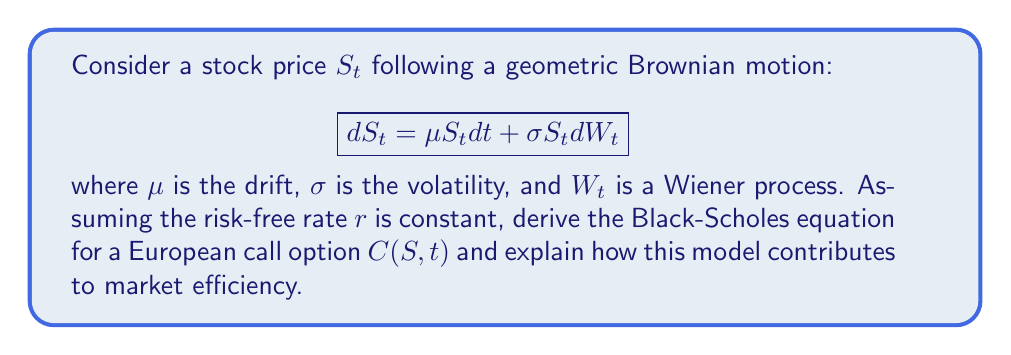Provide a solution to this math problem. 1. Apply Itô's lemma to the function $C(S,t)$:

$$dC = \frac{\partial C}{\partial t}dt + \frac{\partial C}{\partial S}dS + \frac{1}{2}\frac{\partial^2 C}{\partial S^2}(dS)^2$$

2. Substitute $dS = \mu S dt + \sigma S dW$ and $(dS)^2 = \sigma^2 S^2 dt$:

$$dC = \frac{\partial C}{\partial t}dt + \frac{\partial C}{\partial S}(\mu S dt + \sigma S dW) + \frac{1}{2}\frac{\partial^2 C}{\partial S^2}\sigma^2 S^2 dt$$

3. Construct a risk-free portfolio $\Pi = C - \Delta S$ where $\Delta = \frac{\partial C}{\partial S}$:

$$d\Pi = dC - \Delta dS$$

4. Substitute the expressions for $dC$ and $dS$:

$$d\Pi = \left(\frac{\partial C}{\partial t} + \frac{1}{2}\sigma^2 S^2\frac{\partial^2 C}{\partial S^2}\right)dt$$

5. For no arbitrage, the return on this portfolio must equal the risk-free rate:

$$d\Pi = r\Pi dt = r(C - \Delta S)dt$$

6. Equate these expressions and rearrange to get the Black-Scholes equation:

$$\frac{\partial C}{\partial t} + \frac{1}{2}\sigma^2 S^2\frac{\partial^2 C}{\partial S^2} + rS\frac{\partial C}{\partial S} - rC = 0$$

This model contributes to market efficiency by providing a theoretical framework for pricing options, which helps to reduce arbitrage opportunities and align option prices with their underlying assets. It assumes that markets are efficient and incorporate all available information, which aligns with the economic perspective that emphasizes current market dynamics over historical events.
Answer: Black-Scholes equation: $\frac{\partial C}{\partial t} + \frac{1}{2}\sigma^2 S^2\frac{\partial^2 C}{\partial S^2} + rS\frac{\partial C}{\partial S} - rC = 0$ 